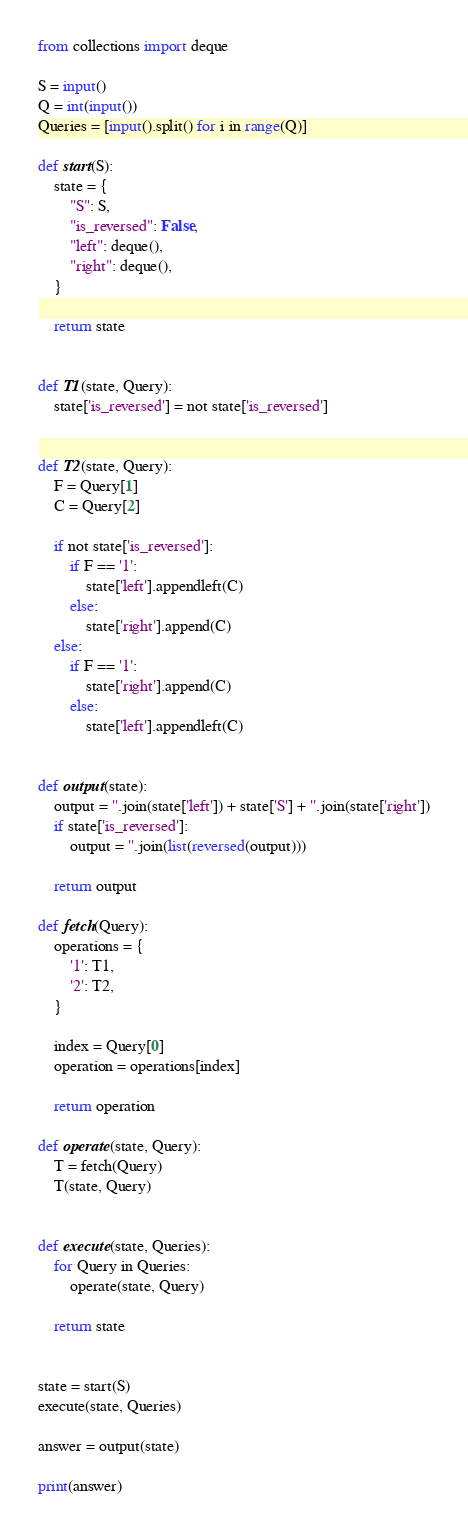<code> <loc_0><loc_0><loc_500><loc_500><_Python_>from collections import deque

S = input()
Q = int(input())
Queries = [input().split() for i in range(Q)]

def start(S):
    state = {
        "S": S,
        "is_reversed": False,
        "left": deque(),
        "right": deque(),
    }

    return state


def T1(state, Query):
    state['is_reversed'] = not state['is_reversed']


def T2(state, Query):
    F = Query[1]
    C = Query[2]

    if not state['is_reversed']:
        if F == '1':
            state['left'].appendleft(C)
        else:
            state['right'].append(C)
    else:
        if F == '1':
            state['right'].append(C)
        else:
            state['left'].appendleft(C)


def output(state):
    output = ''.join(state['left']) + state['S'] + ''.join(state['right'])
    if state['is_reversed']:
        output = ''.join(list(reversed(output)))

    return output

def fetch(Query):
    operations = {
        '1': T1,
        '2': T2,
    }

    index = Query[0]
    operation = operations[index]

    return operation

def operate(state, Query):
    T = fetch(Query)
    T(state, Query)


def execute(state, Queries):
    for Query in Queries:
        operate(state, Query)

    return state


state = start(S)
execute(state, Queries)

answer = output(state)

print(answer)
</code> 